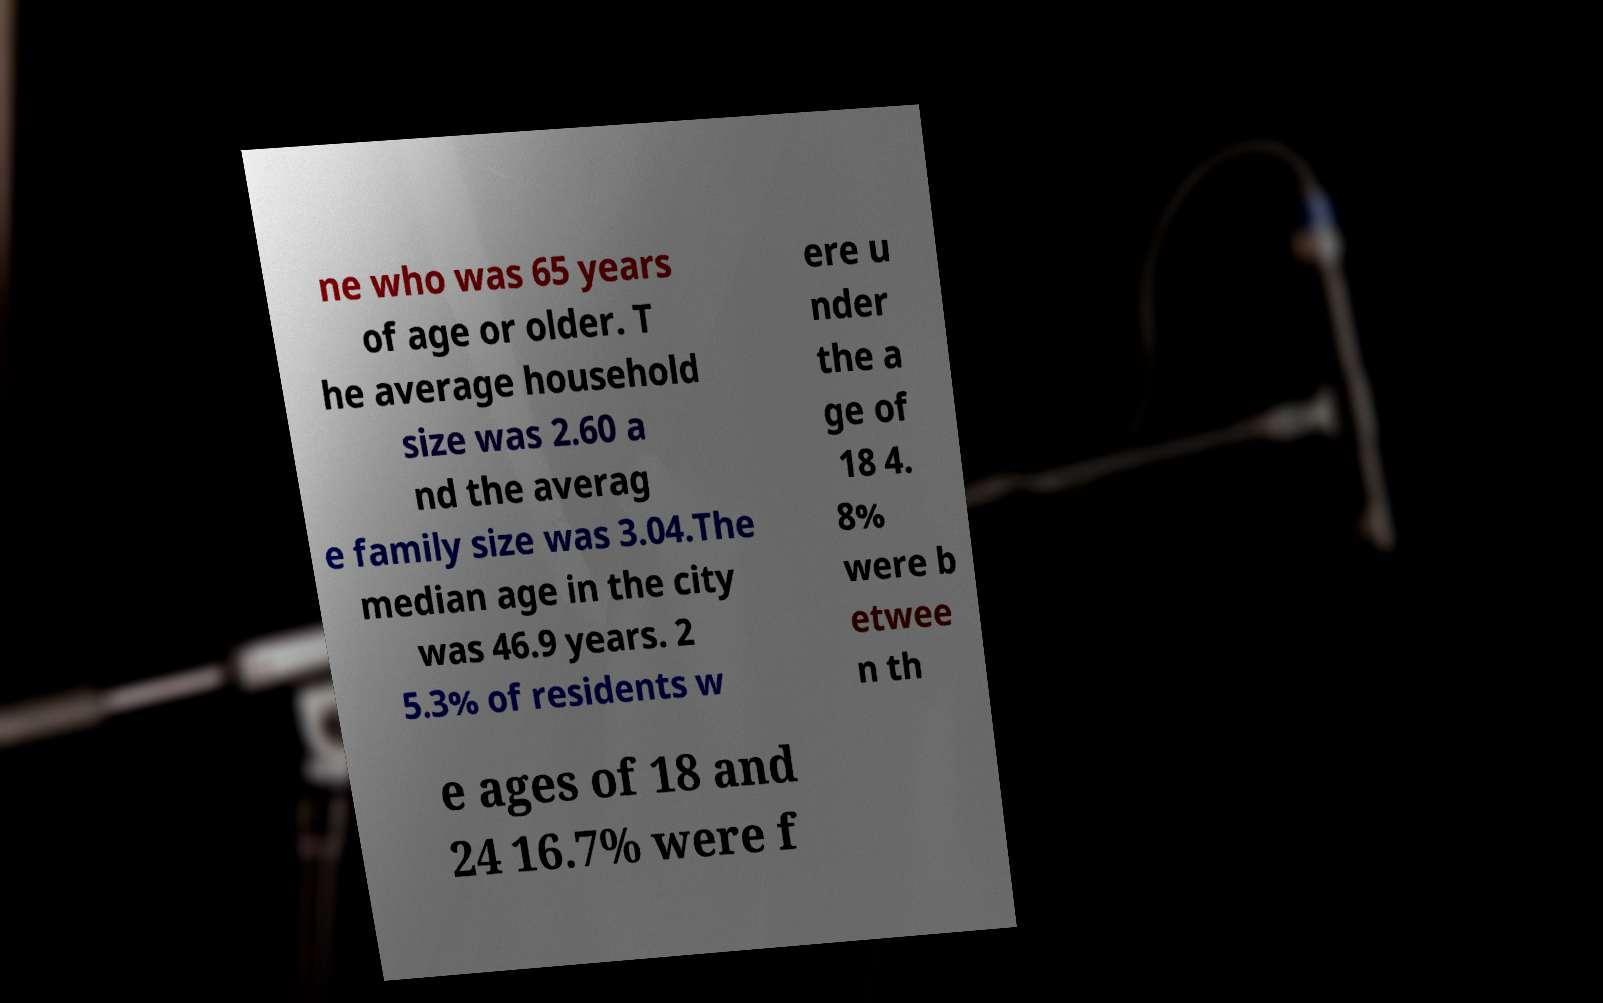There's text embedded in this image that I need extracted. Can you transcribe it verbatim? ne who was 65 years of age or older. T he average household size was 2.60 a nd the averag e family size was 3.04.The median age in the city was 46.9 years. 2 5.3% of residents w ere u nder the a ge of 18 4. 8% were b etwee n th e ages of 18 and 24 16.7% were f 